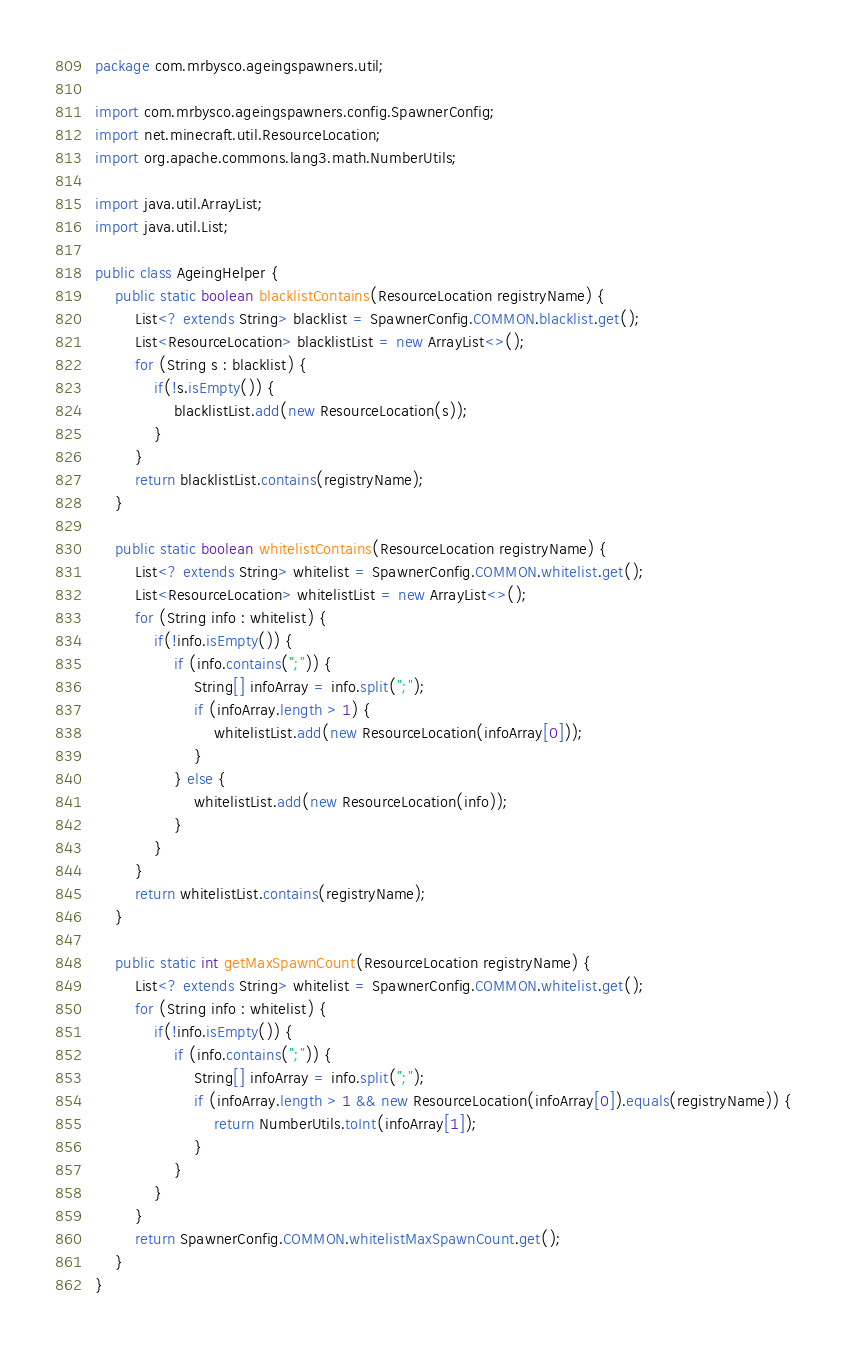<code> <loc_0><loc_0><loc_500><loc_500><_Java_>package com.mrbysco.ageingspawners.util;

import com.mrbysco.ageingspawners.config.SpawnerConfig;
import net.minecraft.util.ResourceLocation;
import org.apache.commons.lang3.math.NumberUtils;

import java.util.ArrayList;
import java.util.List;

public class AgeingHelper {
	public static boolean blacklistContains(ResourceLocation registryName) {
		List<? extends String> blacklist = SpawnerConfig.COMMON.blacklist.get();
		List<ResourceLocation> blacklistList = new ArrayList<>();
		for (String s : blacklist) {
			if(!s.isEmpty()) {
				blacklistList.add(new ResourceLocation(s));
			}
		}
		return blacklistList.contains(registryName);
	}

	public static boolean whitelistContains(ResourceLocation registryName) {
		List<? extends String> whitelist = SpawnerConfig.COMMON.whitelist.get();
		List<ResourceLocation> whitelistList = new ArrayList<>();
		for (String info : whitelist) {
			if(!info.isEmpty()) {
				if (info.contains(";")) {
					String[] infoArray = info.split(";");
					if (infoArray.length > 1) {
						whitelistList.add(new ResourceLocation(infoArray[0]));
					}
				} else {
					whitelistList.add(new ResourceLocation(info));
				}
			}
		}
		return whitelistList.contains(registryName);
	}

	public static int getMaxSpawnCount(ResourceLocation registryName) {
		List<? extends String> whitelist = SpawnerConfig.COMMON.whitelist.get();
		for (String info : whitelist) {
			if(!info.isEmpty()) {
				if (info.contains(";")) {
					String[] infoArray = info.split(";");
					if (infoArray.length > 1 && new ResourceLocation(infoArray[0]).equals(registryName)) {
						return NumberUtils.toInt(infoArray[1]);
					}
				}
			}
		}
		return SpawnerConfig.COMMON.whitelistMaxSpawnCount.get();
	}
}
</code> 